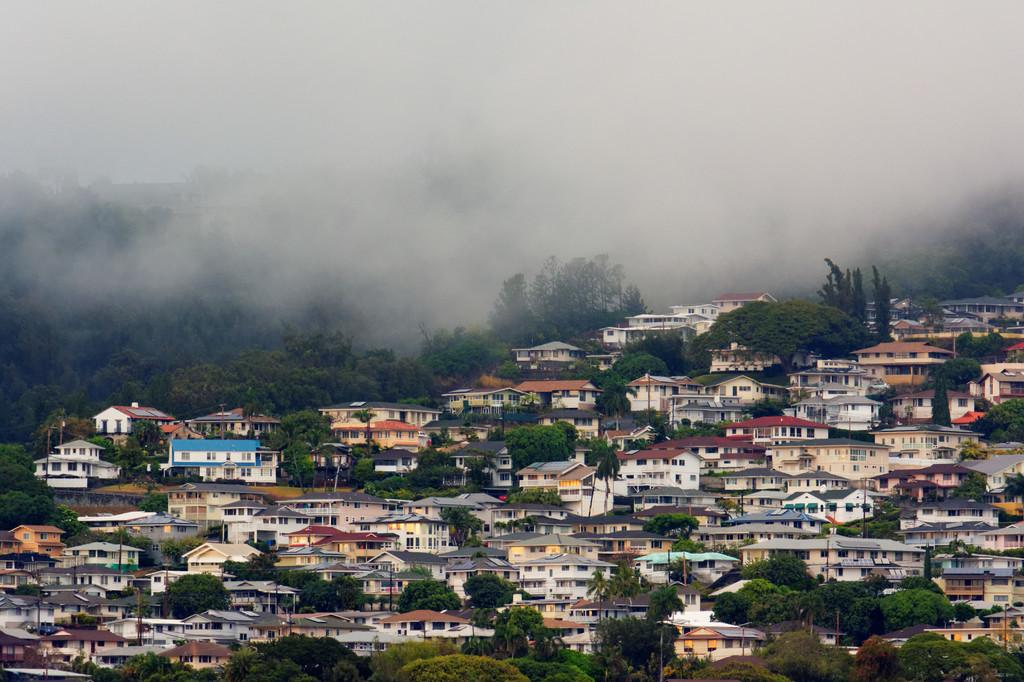What type of buildings can be seen in the image? There are houses with roofs, walls, and windows in the image. What natural elements are present in the image? There are many trees in the image. What atmospheric condition can be observed in the image? There is fog visible in the image. What type of bomb is being dropped in the image? There is no bomb present in the image; it features houses, trees, and fog. What historical event is depicted in the image? The image does not depict any specific historical event; it shows a scene with houses, trees, and fog. 